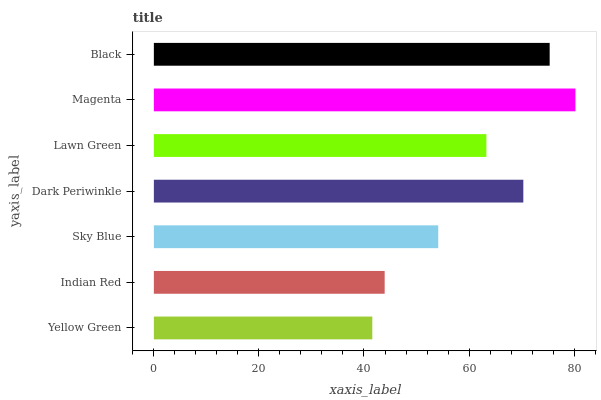Is Yellow Green the minimum?
Answer yes or no. Yes. Is Magenta the maximum?
Answer yes or no. Yes. Is Indian Red the minimum?
Answer yes or no. No. Is Indian Red the maximum?
Answer yes or no. No. Is Indian Red greater than Yellow Green?
Answer yes or no. Yes. Is Yellow Green less than Indian Red?
Answer yes or no. Yes. Is Yellow Green greater than Indian Red?
Answer yes or no. No. Is Indian Red less than Yellow Green?
Answer yes or no. No. Is Lawn Green the high median?
Answer yes or no. Yes. Is Lawn Green the low median?
Answer yes or no. Yes. Is Sky Blue the high median?
Answer yes or no. No. Is Magenta the low median?
Answer yes or no. No. 